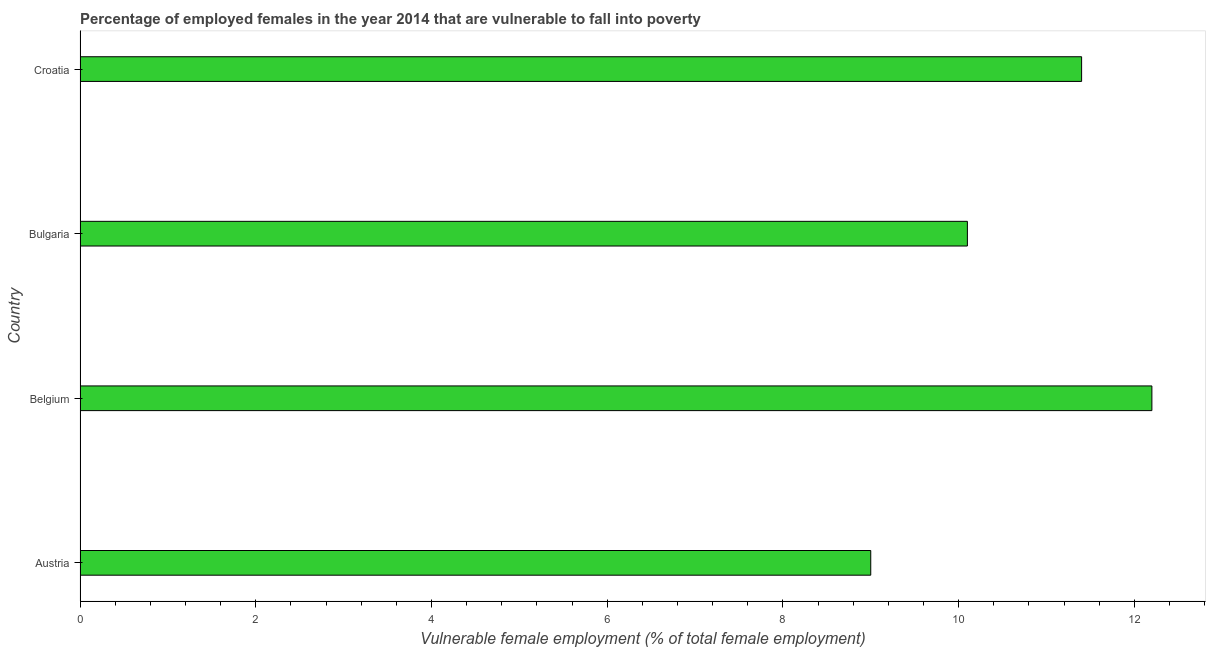Does the graph contain grids?
Ensure brevity in your answer.  No. What is the title of the graph?
Provide a short and direct response. Percentage of employed females in the year 2014 that are vulnerable to fall into poverty. What is the label or title of the X-axis?
Ensure brevity in your answer.  Vulnerable female employment (% of total female employment). What is the label or title of the Y-axis?
Your response must be concise. Country. What is the percentage of employed females who are vulnerable to fall into poverty in Bulgaria?
Offer a terse response. 10.1. Across all countries, what is the maximum percentage of employed females who are vulnerable to fall into poverty?
Your answer should be compact. 12.2. In which country was the percentage of employed females who are vulnerable to fall into poverty maximum?
Your response must be concise. Belgium. In which country was the percentage of employed females who are vulnerable to fall into poverty minimum?
Provide a short and direct response. Austria. What is the sum of the percentage of employed females who are vulnerable to fall into poverty?
Offer a very short reply. 42.7. What is the difference between the percentage of employed females who are vulnerable to fall into poverty in Austria and Belgium?
Provide a short and direct response. -3.2. What is the average percentage of employed females who are vulnerable to fall into poverty per country?
Make the answer very short. 10.68. What is the median percentage of employed females who are vulnerable to fall into poverty?
Give a very brief answer. 10.75. What is the ratio of the percentage of employed females who are vulnerable to fall into poverty in Belgium to that in Bulgaria?
Offer a very short reply. 1.21. Is the sum of the percentage of employed females who are vulnerable to fall into poverty in Belgium and Croatia greater than the maximum percentage of employed females who are vulnerable to fall into poverty across all countries?
Offer a terse response. Yes. What is the difference between the highest and the lowest percentage of employed females who are vulnerable to fall into poverty?
Your answer should be very brief. 3.2. How many bars are there?
Offer a very short reply. 4. Are all the bars in the graph horizontal?
Your response must be concise. Yes. Are the values on the major ticks of X-axis written in scientific E-notation?
Your answer should be compact. No. What is the Vulnerable female employment (% of total female employment) of Austria?
Your answer should be very brief. 9. What is the Vulnerable female employment (% of total female employment) of Belgium?
Ensure brevity in your answer.  12.2. What is the Vulnerable female employment (% of total female employment) in Bulgaria?
Your response must be concise. 10.1. What is the Vulnerable female employment (% of total female employment) of Croatia?
Provide a succinct answer. 11.4. What is the difference between the Vulnerable female employment (% of total female employment) in Austria and Bulgaria?
Provide a succinct answer. -1.1. What is the difference between the Vulnerable female employment (% of total female employment) in Austria and Croatia?
Your answer should be compact. -2.4. What is the difference between the Vulnerable female employment (% of total female employment) in Belgium and Croatia?
Keep it short and to the point. 0.8. What is the difference between the Vulnerable female employment (% of total female employment) in Bulgaria and Croatia?
Ensure brevity in your answer.  -1.3. What is the ratio of the Vulnerable female employment (% of total female employment) in Austria to that in Belgium?
Your answer should be compact. 0.74. What is the ratio of the Vulnerable female employment (% of total female employment) in Austria to that in Bulgaria?
Your answer should be compact. 0.89. What is the ratio of the Vulnerable female employment (% of total female employment) in Austria to that in Croatia?
Provide a short and direct response. 0.79. What is the ratio of the Vulnerable female employment (% of total female employment) in Belgium to that in Bulgaria?
Keep it short and to the point. 1.21. What is the ratio of the Vulnerable female employment (% of total female employment) in Belgium to that in Croatia?
Make the answer very short. 1.07. What is the ratio of the Vulnerable female employment (% of total female employment) in Bulgaria to that in Croatia?
Ensure brevity in your answer.  0.89. 